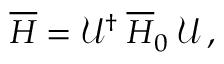<formula> <loc_0><loc_0><loc_500><loc_500>\overline { H } = \mathcal { U } ^ { \dagger } \, \overline { H } _ { 0 } \, \mathcal { U } \, ,</formula> 